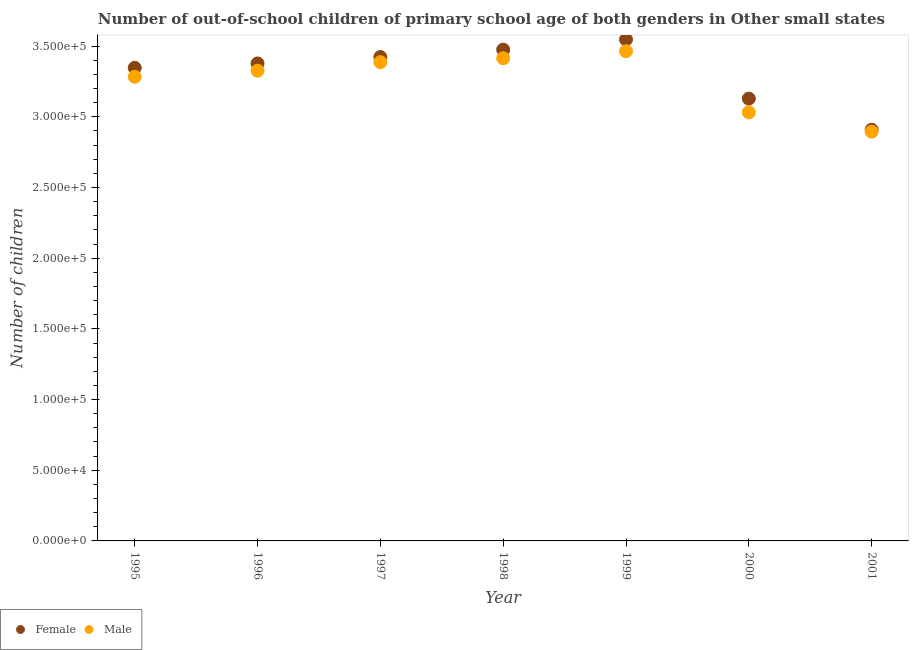How many different coloured dotlines are there?
Provide a short and direct response. 2. Is the number of dotlines equal to the number of legend labels?
Offer a very short reply. Yes. What is the number of male out-of-school students in 1997?
Ensure brevity in your answer.  3.39e+05. Across all years, what is the maximum number of male out-of-school students?
Keep it short and to the point. 3.46e+05. Across all years, what is the minimum number of female out-of-school students?
Make the answer very short. 2.91e+05. What is the total number of female out-of-school students in the graph?
Make the answer very short. 2.32e+06. What is the difference between the number of female out-of-school students in 1995 and that in 2001?
Your response must be concise. 4.38e+04. What is the difference between the number of male out-of-school students in 2001 and the number of female out-of-school students in 1995?
Your answer should be compact. -4.52e+04. What is the average number of male out-of-school students per year?
Your answer should be compact. 3.26e+05. In the year 1999, what is the difference between the number of male out-of-school students and number of female out-of-school students?
Offer a terse response. -8289. What is the ratio of the number of male out-of-school students in 1999 to that in 2001?
Give a very brief answer. 1.2. Is the number of female out-of-school students in 1995 less than that in 1996?
Your response must be concise. Yes. What is the difference between the highest and the second highest number of male out-of-school students?
Make the answer very short. 4992. What is the difference between the highest and the lowest number of male out-of-school students?
Provide a short and direct response. 5.69e+04. Does the number of male out-of-school students monotonically increase over the years?
Keep it short and to the point. No. Is the number of male out-of-school students strictly greater than the number of female out-of-school students over the years?
Ensure brevity in your answer.  No. Is the number of female out-of-school students strictly less than the number of male out-of-school students over the years?
Your answer should be very brief. No. How many dotlines are there?
Offer a very short reply. 2. How many years are there in the graph?
Provide a succinct answer. 7. Are the values on the major ticks of Y-axis written in scientific E-notation?
Your answer should be very brief. Yes. Where does the legend appear in the graph?
Give a very brief answer. Bottom left. How many legend labels are there?
Make the answer very short. 2. How are the legend labels stacked?
Your answer should be very brief. Horizontal. What is the title of the graph?
Your answer should be compact. Number of out-of-school children of primary school age of both genders in Other small states. Does "Central government" appear as one of the legend labels in the graph?
Ensure brevity in your answer.  No. What is the label or title of the Y-axis?
Provide a short and direct response. Number of children. What is the Number of children in Female in 1995?
Your response must be concise. 3.35e+05. What is the Number of children in Male in 1995?
Give a very brief answer. 3.28e+05. What is the Number of children of Female in 1996?
Offer a terse response. 3.38e+05. What is the Number of children of Male in 1996?
Your answer should be compact. 3.33e+05. What is the Number of children of Female in 1997?
Offer a terse response. 3.42e+05. What is the Number of children of Male in 1997?
Offer a terse response. 3.39e+05. What is the Number of children of Female in 1998?
Your answer should be compact. 3.48e+05. What is the Number of children of Male in 1998?
Offer a very short reply. 3.41e+05. What is the Number of children of Female in 1999?
Your answer should be very brief. 3.55e+05. What is the Number of children in Male in 1999?
Your answer should be very brief. 3.46e+05. What is the Number of children in Female in 2000?
Give a very brief answer. 3.13e+05. What is the Number of children of Male in 2000?
Give a very brief answer. 3.03e+05. What is the Number of children of Female in 2001?
Ensure brevity in your answer.  2.91e+05. What is the Number of children in Male in 2001?
Offer a terse response. 2.90e+05. Across all years, what is the maximum Number of children in Female?
Provide a succinct answer. 3.55e+05. Across all years, what is the maximum Number of children in Male?
Provide a succinct answer. 3.46e+05. Across all years, what is the minimum Number of children of Female?
Offer a very short reply. 2.91e+05. Across all years, what is the minimum Number of children in Male?
Provide a short and direct response. 2.90e+05. What is the total Number of children in Female in the graph?
Keep it short and to the point. 2.32e+06. What is the total Number of children in Male in the graph?
Your answer should be very brief. 2.28e+06. What is the difference between the Number of children in Female in 1995 and that in 1996?
Offer a very short reply. -3076. What is the difference between the Number of children of Male in 1995 and that in 1996?
Provide a succinct answer. -4295. What is the difference between the Number of children in Female in 1995 and that in 1997?
Make the answer very short. -7631. What is the difference between the Number of children of Male in 1995 and that in 1997?
Provide a succinct answer. -1.03e+04. What is the difference between the Number of children of Female in 1995 and that in 1998?
Make the answer very short. -1.29e+04. What is the difference between the Number of children of Male in 1995 and that in 1998?
Your answer should be very brief. -1.31e+04. What is the difference between the Number of children of Female in 1995 and that in 1999?
Offer a very short reply. -2.00e+04. What is the difference between the Number of children of Male in 1995 and that in 1999?
Provide a succinct answer. -1.81e+04. What is the difference between the Number of children of Female in 1995 and that in 2000?
Ensure brevity in your answer.  2.18e+04. What is the difference between the Number of children of Male in 1995 and that in 2000?
Keep it short and to the point. 2.51e+04. What is the difference between the Number of children in Female in 1995 and that in 2001?
Provide a succinct answer. 4.38e+04. What is the difference between the Number of children of Male in 1995 and that in 2001?
Your answer should be compact. 3.89e+04. What is the difference between the Number of children in Female in 1996 and that in 1997?
Ensure brevity in your answer.  -4555. What is the difference between the Number of children in Male in 1996 and that in 1997?
Offer a very short reply. -6051. What is the difference between the Number of children in Female in 1996 and that in 1998?
Provide a short and direct response. -9780. What is the difference between the Number of children of Male in 1996 and that in 1998?
Your response must be concise. -8806. What is the difference between the Number of children in Female in 1996 and that in 1999?
Give a very brief answer. -1.70e+04. What is the difference between the Number of children of Male in 1996 and that in 1999?
Offer a terse response. -1.38e+04. What is the difference between the Number of children in Female in 1996 and that in 2000?
Provide a succinct answer. 2.49e+04. What is the difference between the Number of children in Male in 1996 and that in 2000?
Ensure brevity in your answer.  2.94e+04. What is the difference between the Number of children in Female in 1996 and that in 2001?
Give a very brief answer. 4.69e+04. What is the difference between the Number of children in Male in 1996 and that in 2001?
Keep it short and to the point. 4.31e+04. What is the difference between the Number of children in Female in 1997 and that in 1998?
Your answer should be very brief. -5225. What is the difference between the Number of children of Male in 1997 and that in 1998?
Offer a very short reply. -2755. What is the difference between the Number of children of Female in 1997 and that in 1999?
Ensure brevity in your answer.  -1.24e+04. What is the difference between the Number of children of Male in 1997 and that in 1999?
Provide a short and direct response. -7747. What is the difference between the Number of children of Female in 1997 and that in 2000?
Keep it short and to the point. 2.94e+04. What is the difference between the Number of children of Male in 1997 and that in 2000?
Your answer should be very brief. 3.55e+04. What is the difference between the Number of children of Female in 1997 and that in 2001?
Offer a terse response. 5.14e+04. What is the difference between the Number of children of Male in 1997 and that in 2001?
Your answer should be very brief. 4.92e+04. What is the difference between the Number of children in Female in 1998 and that in 1999?
Offer a terse response. -7178. What is the difference between the Number of children in Male in 1998 and that in 1999?
Your response must be concise. -4992. What is the difference between the Number of children of Female in 1998 and that in 2000?
Your response must be concise. 3.47e+04. What is the difference between the Number of children of Male in 1998 and that in 2000?
Your answer should be compact. 3.82e+04. What is the difference between the Number of children of Female in 1998 and that in 2001?
Your response must be concise. 5.67e+04. What is the difference between the Number of children in Male in 1998 and that in 2001?
Keep it short and to the point. 5.20e+04. What is the difference between the Number of children in Female in 1999 and that in 2000?
Your response must be concise. 4.18e+04. What is the difference between the Number of children in Male in 1999 and that in 2000?
Provide a succinct answer. 4.32e+04. What is the difference between the Number of children of Female in 1999 and that in 2001?
Your response must be concise. 6.38e+04. What is the difference between the Number of children in Male in 1999 and that in 2001?
Keep it short and to the point. 5.69e+04. What is the difference between the Number of children of Female in 2000 and that in 2001?
Your response must be concise. 2.20e+04. What is the difference between the Number of children in Male in 2000 and that in 2001?
Give a very brief answer. 1.37e+04. What is the difference between the Number of children of Female in 1995 and the Number of children of Male in 1996?
Your answer should be compact. 2053. What is the difference between the Number of children of Female in 1995 and the Number of children of Male in 1997?
Your answer should be compact. -3998. What is the difference between the Number of children of Female in 1995 and the Number of children of Male in 1998?
Keep it short and to the point. -6753. What is the difference between the Number of children in Female in 1995 and the Number of children in Male in 1999?
Your response must be concise. -1.17e+04. What is the difference between the Number of children in Female in 1995 and the Number of children in Male in 2000?
Keep it short and to the point. 3.15e+04. What is the difference between the Number of children in Female in 1995 and the Number of children in Male in 2001?
Keep it short and to the point. 4.52e+04. What is the difference between the Number of children in Female in 1996 and the Number of children in Male in 1997?
Provide a succinct answer. -922. What is the difference between the Number of children of Female in 1996 and the Number of children of Male in 1998?
Make the answer very short. -3677. What is the difference between the Number of children in Female in 1996 and the Number of children in Male in 1999?
Give a very brief answer. -8669. What is the difference between the Number of children of Female in 1996 and the Number of children of Male in 2000?
Provide a short and direct response. 3.46e+04. What is the difference between the Number of children in Female in 1996 and the Number of children in Male in 2001?
Give a very brief answer. 4.83e+04. What is the difference between the Number of children in Female in 1997 and the Number of children in Male in 1998?
Provide a short and direct response. 878. What is the difference between the Number of children of Female in 1997 and the Number of children of Male in 1999?
Ensure brevity in your answer.  -4114. What is the difference between the Number of children of Female in 1997 and the Number of children of Male in 2000?
Give a very brief answer. 3.91e+04. What is the difference between the Number of children of Female in 1997 and the Number of children of Male in 2001?
Ensure brevity in your answer.  5.28e+04. What is the difference between the Number of children of Female in 1998 and the Number of children of Male in 1999?
Keep it short and to the point. 1111. What is the difference between the Number of children in Female in 1998 and the Number of children in Male in 2000?
Make the answer very short. 4.43e+04. What is the difference between the Number of children of Female in 1998 and the Number of children of Male in 2001?
Your answer should be compact. 5.81e+04. What is the difference between the Number of children of Female in 1999 and the Number of children of Male in 2000?
Your answer should be compact. 5.15e+04. What is the difference between the Number of children in Female in 1999 and the Number of children in Male in 2001?
Give a very brief answer. 6.52e+04. What is the difference between the Number of children of Female in 2000 and the Number of children of Male in 2001?
Provide a short and direct response. 2.34e+04. What is the average Number of children of Female per year?
Give a very brief answer. 3.32e+05. What is the average Number of children of Male per year?
Your response must be concise. 3.26e+05. In the year 1995, what is the difference between the Number of children of Female and Number of children of Male?
Keep it short and to the point. 6348. In the year 1996, what is the difference between the Number of children in Female and Number of children in Male?
Offer a terse response. 5129. In the year 1997, what is the difference between the Number of children of Female and Number of children of Male?
Offer a very short reply. 3633. In the year 1998, what is the difference between the Number of children in Female and Number of children in Male?
Your response must be concise. 6103. In the year 1999, what is the difference between the Number of children in Female and Number of children in Male?
Give a very brief answer. 8289. In the year 2000, what is the difference between the Number of children in Female and Number of children in Male?
Give a very brief answer. 9688. In the year 2001, what is the difference between the Number of children in Female and Number of children in Male?
Give a very brief answer. 1387. What is the ratio of the Number of children in Female in 1995 to that in 1996?
Offer a very short reply. 0.99. What is the ratio of the Number of children in Male in 1995 to that in 1996?
Make the answer very short. 0.99. What is the ratio of the Number of children of Female in 1995 to that in 1997?
Ensure brevity in your answer.  0.98. What is the ratio of the Number of children in Male in 1995 to that in 1997?
Provide a succinct answer. 0.97. What is the ratio of the Number of children in Female in 1995 to that in 1998?
Give a very brief answer. 0.96. What is the ratio of the Number of children in Male in 1995 to that in 1998?
Ensure brevity in your answer.  0.96. What is the ratio of the Number of children in Female in 1995 to that in 1999?
Offer a terse response. 0.94. What is the ratio of the Number of children of Male in 1995 to that in 1999?
Offer a terse response. 0.95. What is the ratio of the Number of children in Female in 1995 to that in 2000?
Offer a very short reply. 1.07. What is the ratio of the Number of children in Male in 1995 to that in 2000?
Offer a terse response. 1.08. What is the ratio of the Number of children of Female in 1995 to that in 2001?
Offer a terse response. 1.15. What is the ratio of the Number of children in Male in 1995 to that in 2001?
Offer a terse response. 1.13. What is the ratio of the Number of children of Female in 1996 to that in 1997?
Ensure brevity in your answer.  0.99. What is the ratio of the Number of children of Male in 1996 to that in 1997?
Your answer should be very brief. 0.98. What is the ratio of the Number of children of Female in 1996 to that in 1998?
Your answer should be compact. 0.97. What is the ratio of the Number of children of Male in 1996 to that in 1998?
Give a very brief answer. 0.97. What is the ratio of the Number of children of Female in 1996 to that in 1999?
Give a very brief answer. 0.95. What is the ratio of the Number of children of Male in 1996 to that in 1999?
Your answer should be compact. 0.96. What is the ratio of the Number of children in Female in 1996 to that in 2000?
Provide a succinct answer. 1.08. What is the ratio of the Number of children in Male in 1996 to that in 2000?
Your response must be concise. 1.1. What is the ratio of the Number of children of Female in 1996 to that in 2001?
Offer a terse response. 1.16. What is the ratio of the Number of children of Male in 1996 to that in 2001?
Provide a succinct answer. 1.15. What is the ratio of the Number of children in Male in 1997 to that in 1999?
Ensure brevity in your answer.  0.98. What is the ratio of the Number of children of Female in 1997 to that in 2000?
Your answer should be compact. 1.09. What is the ratio of the Number of children in Male in 1997 to that in 2000?
Keep it short and to the point. 1.12. What is the ratio of the Number of children in Female in 1997 to that in 2001?
Offer a very short reply. 1.18. What is the ratio of the Number of children in Male in 1997 to that in 2001?
Provide a succinct answer. 1.17. What is the ratio of the Number of children in Female in 1998 to that in 1999?
Offer a terse response. 0.98. What is the ratio of the Number of children in Male in 1998 to that in 1999?
Your answer should be compact. 0.99. What is the ratio of the Number of children in Female in 1998 to that in 2000?
Your response must be concise. 1.11. What is the ratio of the Number of children of Male in 1998 to that in 2000?
Your answer should be very brief. 1.13. What is the ratio of the Number of children in Female in 1998 to that in 2001?
Give a very brief answer. 1.19. What is the ratio of the Number of children in Male in 1998 to that in 2001?
Keep it short and to the point. 1.18. What is the ratio of the Number of children of Female in 1999 to that in 2000?
Provide a succinct answer. 1.13. What is the ratio of the Number of children in Male in 1999 to that in 2000?
Ensure brevity in your answer.  1.14. What is the ratio of the Number of children in Female in 1999 to that in 2001?
Keep it short and to the point. 1.22. What is the ratio of the Number of children of Male in 1999 to that in 2001?
Provide a short and direct response. 1.2. What is the ratio of the Number of children in Female in 2000 to that in 2001?
Your answer should be very brief. 1.08. What is the ratio of the Number of children of Male in 2000 to that in 2001?
Your answer should be very brief. 1.05. What is the difference between the highest and the second highest Number of children of Female?
Your response must be concise. 7178. What is the difference between the highest and the second highest Number of children of Male?
Your answer should be very brief. 4992. What is the difference between the highest and the lowest Number of children in Female?
Your answer should be very brief. 6.38e+04. What is the difference between the highest and the lowest Number of children in Male?
Ensure brevity in your answer.  5.69e+04. 